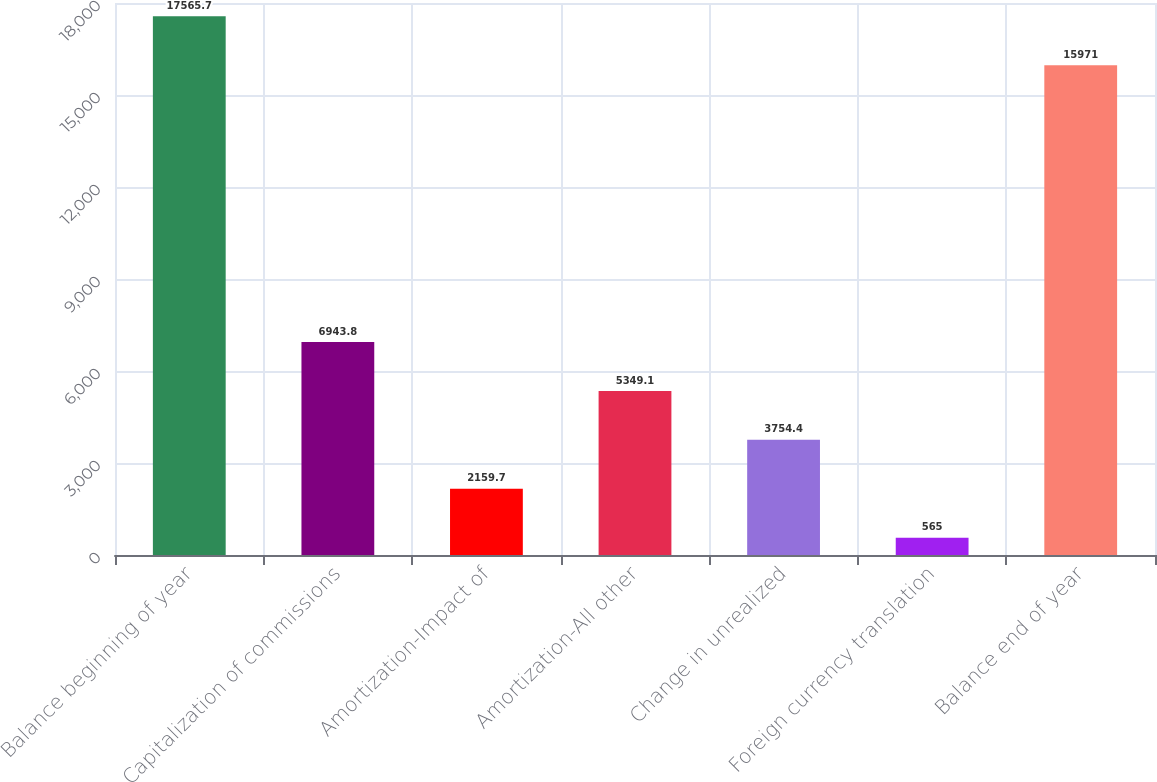Convert chart to OTSL. <chart><loc_0><loc_0><loc_500><loc_500><bar_chart><fcel>Balance beginning of year<fcel>Capitalization of commissions<fcel>Amortization-Impact of<fcel>Amortization-All other<fcel>Change in unrealized<fcel>Foreign currency translation<fcel>Balance end of year<nl><fcel>17565.7<fcel>6943.8<fcel>2159.7<fcel>5349.1<fcel>3754.4<fcel>565<fcel>15971<nl></chart> 